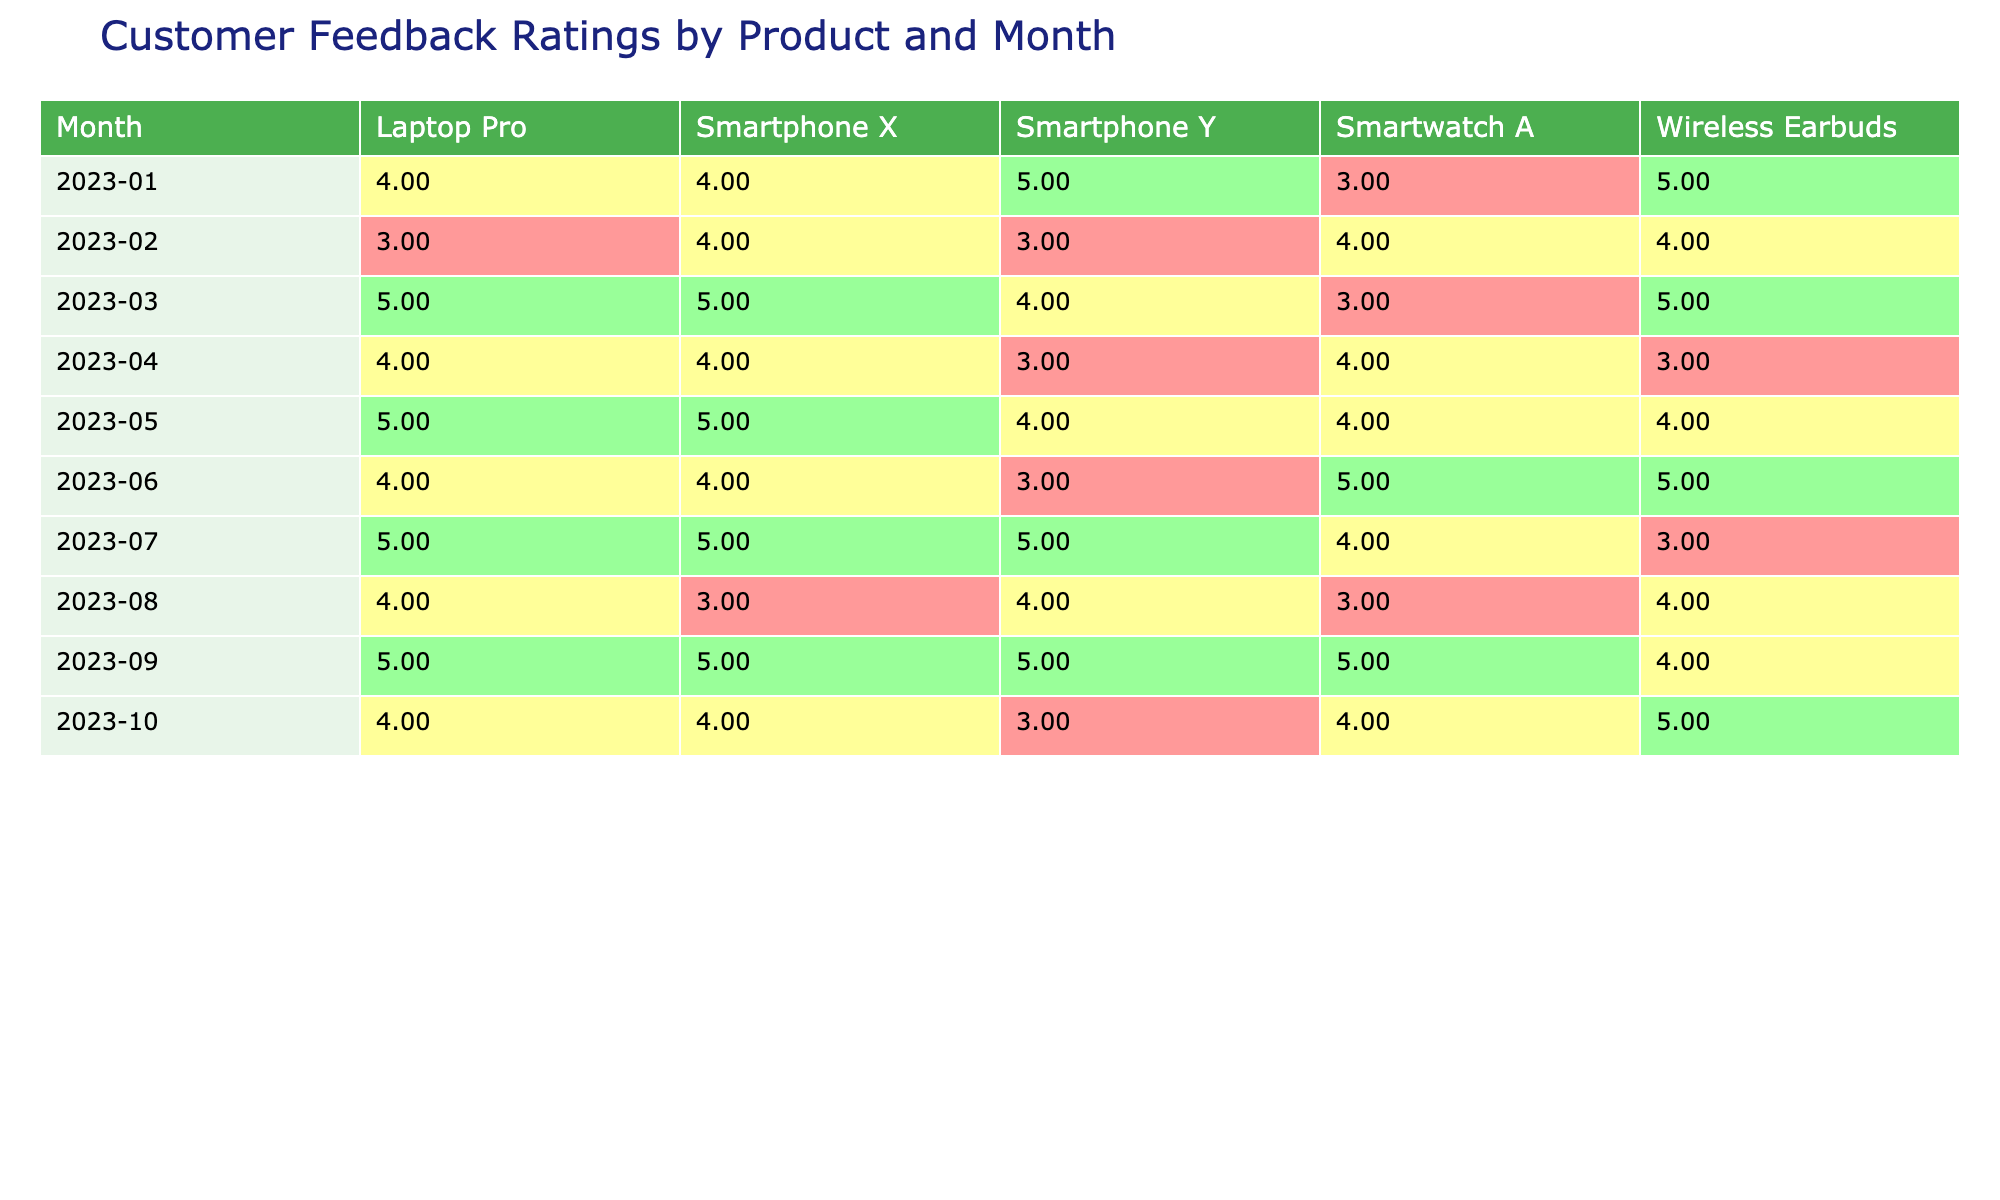What is the average customer feedback rating for Smartphone X in March 2023? The feedback ratings for Smartphone X in March 2023 is 5. Therefore, the average rating is simply 5.
Answer: 5 What was the customer feedback rating for Wireless Earbuds in April 2023? In April 2023, the customer feedback rating for Wireless Earbuds is 3.
Answer: 3 Which product received the highest feedback rating in May 2023? In May 2023, Laptop Pro received the highest feedback rating of 5.
Answer: Laptop Pro Is the feedback rating for Smartwatch A in June 2023 higher than the rating for Smartphone Y in the same month? Smartwatch A received a rating of 5 in June 2023, while Smartphone Y received a rating of 3. Thus, the rating for Smartwatch A is higher.
Answer: Yes What is the total customer feedback rating for all products in March 2023? The ratings for March 2023 are: Smartphone X (5), Smartphone Y (4), Smartwatch A (3), Laptop Pro (5), and Wireless Earbuds (5). Summing these gives 5 + 4 + 3 + 5 + 5 = 22.
Answer: 22 What were the average customer feedback ratings across all products for the month of August 2023? The ratings in August 2023 are: Smartphone X (3), Smartphone Y (4), Smartwatch A (3), Laptop Pro (4), and Wireless Earbuds (4). The average is (3 + 4 + 3 + 4 + 4) / 5 = 3.6.
Answer: 3.6 Was the overall customer feedback for Smartphone Y consistent in the first three months of 2023? The ratings for Smartphone Y are: January 2023 (5), February 2023 (3), March 2023 (4). Since the ratings vary, they are not consistent.
Answer: No In which month did Wireless Earbuds achieve their best rating? The best rating for Wireless Earbuds is 5, which they achieved in March and June 2023.
Answer: March and June 2023 How many products received a feedback rating of 4 in July 2023? In July 2023, the feedback ratings for products were: Smartphone X (5), Smartphone Y (5), Smartwatch A (4), Laptop Pro (5), and Wireless Earbuds (3). Here, only Smartwatch A received a rating of 4.
Answer: 1 What was the difference in average feedback ratings between Laptop Pro and Smartwatch A for the period of January to March 2023? The average ratings are: Laptop Pro (January 4, February 3, March 5) = (4 + 3 + 5) / 3 = 4; Smartwatch A (January 3, February 4, March 3) = (3 + 4 + 3) / 3 = 3.33; the difference is 4 - 3.33 = 0.67.
Answer: 0.67 Did any product consistently receive a feedback rating of 5 across all ten months? Upon reviewing the table, there are no products that consistently received a rating of 5 across all months; each product fluctuated.
Answer: No 